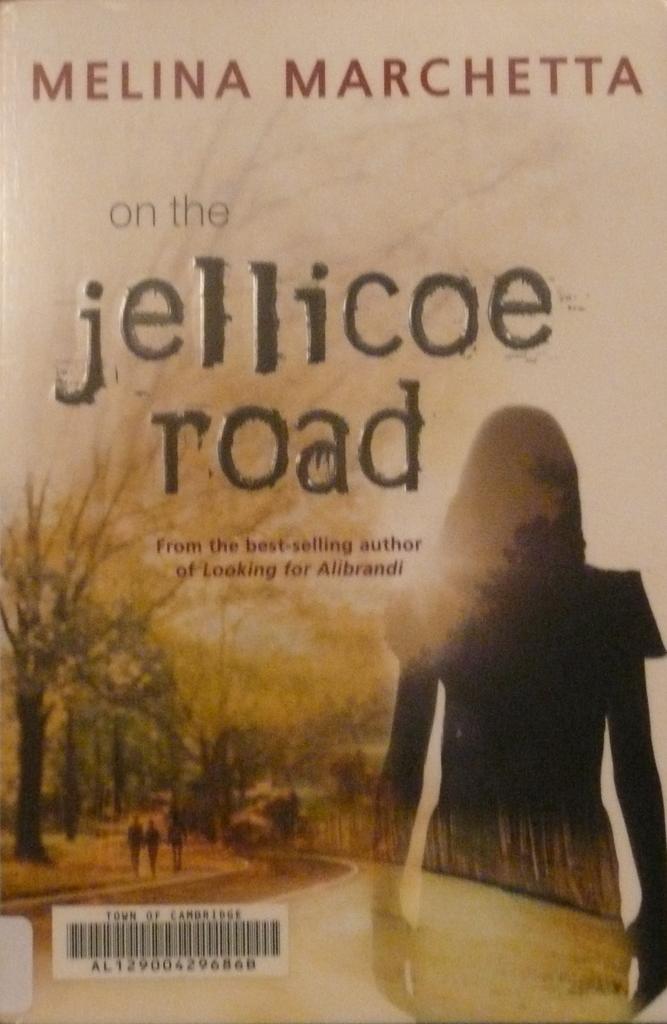Who is the author of this book?
Give a very brief answer. Melina marchetta. What road is in the title?
Make the answer very short. Jellicoe. 